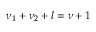Convert formula to latex. <formula><loc_0><loc_0><loc_500><loc_500>\nu _ { 1 } + \nu _ { 2 } + l = \nu + 1</formula> 